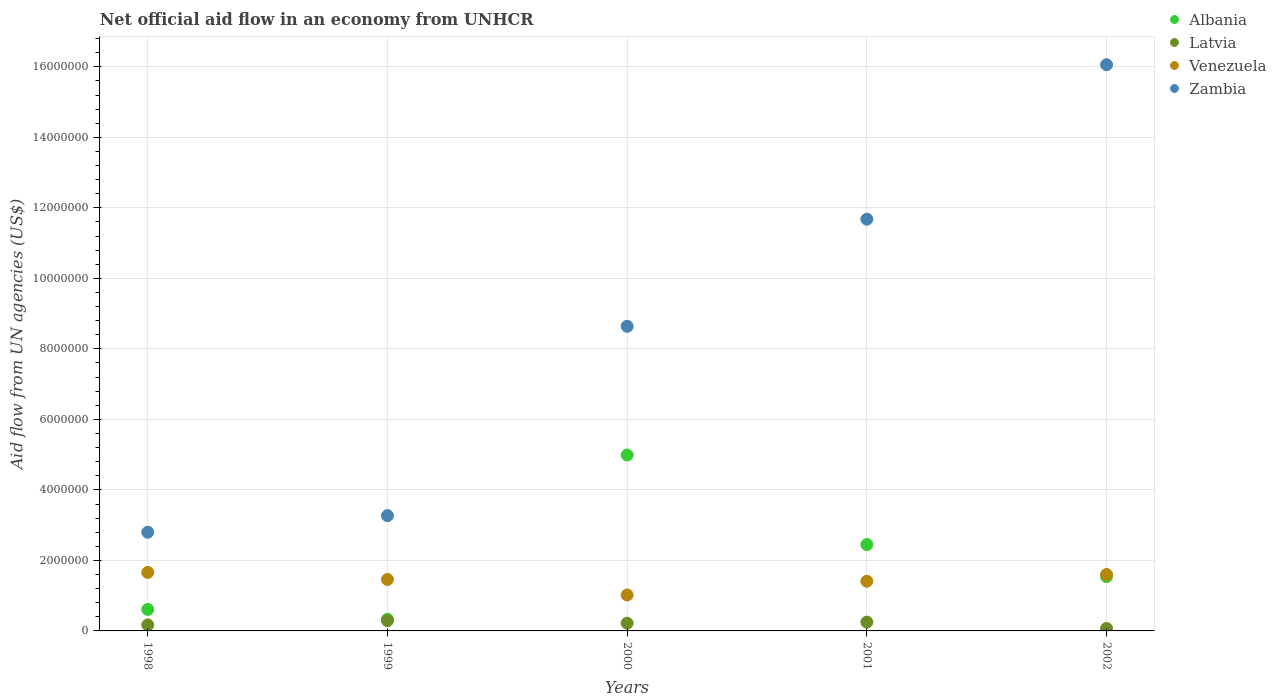Is the number of dotlines equal to the number of legend labels?
Make the answer very short. Yes. What is the net official aid flow in Venezuela in 2001?
Offer a terse response. 1.41e+06. Across all years, what is the maximum net official aid flow in Venezuela?
Offer a very short reply. 1.66e+06. Across all years, what is the minimum net official aid flow in Venezuela?
Keep it short and to the point. 1.02e+06. In which year was the net official aid flow in Albania maximum?
Your response must be concise. 2000. What is the total net official aid flow in Latvia in the graph?
Ensure brevity in your answer.  1.00e+06. What is the difference between the net official aid flow in Albania in 2002 and the net official aid flow in Venezuela in 2000?
Your answer should be compact. 5.20e+05. What is the average net official aid flow in Zambia per year?
Give a very brief answer. 8.49e+06. In the year 2000, what is the difference between the net official aid flow in Latvia and net official aid flow in Venezuela?
Your response must be concise. -8.00e+05. What is the ratio of the net official aid flow in Albania in 1999 to that in 2001?
Offer a terse response. 0.13. Is the net official aid flow in Albania in 2000 less than that in 2001?
Your answer should be very brief. No. Is the difference between the net official aid flow in Latvia in 1998 and 1999 greater than the difference between the net official aid flow in Venezuela in 1998 and 1999?
Offer a terse response. No. What is the difference between the highest and the second highest net official aid flow in Venezuela?
Your response must be concise. 6.00e+04. What is the difference between the highest and the lowest net official aid flow in Latvia?
Your answer should be very brief. 2.20e+05. In how many years, is the net official aid flow in Venezuela greater than the average net official aid flow in Venezuela taken over all years?
Offer a terse response. 3. Is the sum of the net official aid flow in Venezuela in 1998 and 1999 greater than the maximum net official aid flow in Albania across all years?
Your answer should be very brief. No. Is it the case that in every year, the sum of the net official aid flow in Venezuela and net official aid flow in Zambia  is greater than the sum of net official aid flow in Albania and net official aid flow in Latvia?
Offer a very short reply. Yes. Is the net official aid flow in Latvia strictly less than the net official aid flow in Venezuela over the years?
Your answer should be compact. Yes. How many years are there in the graph?
Provide a succinct answer. 5. Does the graph contain any zero values?
Your answer should be compact. No. Does the graph contain grids?
Ensure brevity in your answer.  Yes. How many legend labels are there?
Ensure brevity in your answer.  4. How are the legend labels stacked?
Your answer should be very brief. Vertical. What is the title of the graph?
Keep it short and to the point. Net official aid flow in an economy from UNHCR. Does "Rwanda" appear as one of the legend labels in the graph?
Your answer should be very brief. No. What is the label or title of the Y-axis?
Provide a short and direct response. Aid flow from UN agencies (US$). What is the Aid flow from UN agencies (US$) in Albania in 1998?
Your response must be concise. 6.10e+05. What is the Aid flow from UN agencies (US$) in Venezuela in 1998?
Your response must be concise. 1.66e+06. What is the Aid flow from UN agencies (US$) in Zambia in 1998?
Keep it short and to the point. 2.80e+06. What is the Aid flow from UN agencies (US$) of Albania in 1999?
Provide a short and direct response. 3.30e+05. What is the Aid flow from UN agencies (US$) in Latvia in 1999?
Make the answer very short. 2.90e+05. What is the Aid flow from UN agencies (US$) in Venezuela in 1999?
Give a very brief answer. 1.46e+06. What is the Aid flow from UN agencies (US$) in Zambia in 1999?
Make the answer very short. 3.27e+06. What is the Aid flow from UN agencies (US$) in Albania in 2000?
Your answer should be compact. 4.99e+06. What is the Aid flow from UN agencies (US$) of Venezuela in 2000?
Your answer should be compact. 1.02e+06. What is the Aid flow from UN agencies (US$) of Zambia in 2000?
Make the answer very short. 8.64e+06. What is the Aid flow from UN agencies (US$) of Albania in 2001?
Your response must be concise. 2.45e+06. What is the Aid flow from UN agencies (US$) in Venezuela in 2001?
Ensure brevity in your answer.  1.41e+06. What is the Aid flow from UN agencies (US$) in Zambia in 2001?
Ensure brevity in your answer.  1.17e+07. What is the Aid flow from UN agencies (US$) in Albania in 2002?
Give a very brief answer. 1.54e+06. What is the Aid flow from UN agencies (US$) of Venezuela in 2002?
Keep it short and to the point. 1.60e+06. What is the Aid flow from UN agencies (US$) of Zambia in 2002?
Your answer should be very brief. 1.61e+07. Across all years, what is the maximum Aid flow from UN agencies (US$) of Albania?
Make the answer very short. 4.99e+06. Across all years, what is the maximum Aid flow from UN agencies (US$) in Venezuela?
Give a very brief answer. 1.66e+06. Across all years, what is the maximum Aid flow from UN agencies (US$) in Zambia?
Give a very brief answer. 1.61e+07. Across all years, what is the minimum Aid flow from UN agencies (US$) in Albania?
Give a very brief answer. 3.30e+05. Across all years, what is the minimum Aid flow from UN agencies (US$) in Venezuela?
Offer a terse response. 1.02e+06. Across all years, what is the minimum Aid flow from UN agencies (US$) in Zambia?
Provide a succinct answer. 2.80e+06. What is the total Aid flow from UN agencies (US$) of Albania in the graph?
Your answer should be very brief. 9.92e+06. What is the total Aid flow from UN agencies (US$) in Latvia in the graph?
Ensure brevity in your answer.  1.00e+06. What is the total Aid flow from UN agencies (US$) in Venezuela in the graph?
Offer a very short reply. 7.15e+06. What is the total Aid flow from UN agencies (US$) of Zambia in the graph?
Your response must be concise. 4.24e+07. What is the difference between the Aid flow from UN agencies (US$) of Albania in 1998 and that in 1999?
Your response must be concise. 2.80e+05. What is the difference between the Aid flow from UN agencies (US$) of Latvia in 1998 and that in 1999?
Keep it short and to the point. -1.20e+05. What is the difference between the Aid flow from UN agencies (US$) in Venezuela in 1998 and that in 1999?
Offer a very short reply. 2.00e+05. What is the difference between the Aid flow from UN agencies (US$) of Zambia in 1998 and that in 1999?
Keep it short and to the point. -4.70e+05. What is the difference between the Aid flow from UN agencies (US$) of Albania in 1998 and that in 2000?
Keep it short and to the point. -4.38e+06. What is the difference between the Aid flow from UN agencies (US$) in Venezuela in 1998 and that in 2000?
Your response must be concise. 6.40e+05. What is the difference between the Aid flow from UN agencies (US$) in Zambia in 1998 and that in 2000?
Your answer should be very brief. -5.84e+06. What is the difference between the Aid flow from UN agencies (US$) of Albania in 1998 and that in 2001?
Make the answer very short. -1.84e+06. What is the difference between the Aid flow from UN agencies (US$) of Zambia in 1998 and that in 2001?
Ensure brevity in your answer.  -8.88e+06. What is the difference between the Aid flow from UN agencies (US$) in Albania in 1998 and that in 2002?
Your answer should be compact. -9.30e+05. What is the difference between the Aid flow from UN agencies (US$) in Venezuela in 1998 and that in 2002?
Ensure brevity in your answer.  6.00e+04. What is the difference between the Aid flow from UN agencies (US$) of Zambia in 1998 and that in 2002?
Your answer should be compact. -1.33e+07. What is the difference between the Aid flow from UN agencies (US$) of Albania in 1999 and that in 2000?
Your response must be concise. -4.66e+06. What is the difference between the Aid flow from UN agencies (US$) of Venezuela in 1999 and that in 2000?
Ensure brevity in your answer.  4.40e+05. What is the difference between the Aid flow from UN agencies (US$) in Zambia in 1999 and that in 2000?
Make the answer very short. -5.37e+06. What is the difference between the Aid flow from UN agencies (US$) in Albania in 1999 and that in 2001?
Offer a very short reply. -2.12e+06. What is the difference between the Aid flow from UN agencies (US$) of Latvia in 1999 and that in 2001?
Give a very brief answer. 4.00e+04. What is the difference between the Aid flow from UN agencies (US$) of Venezuela in 1999 and that in 2001?
Offer a very short reply. 5.00e+04. What is the difference between the Aid flow from UN agencies (US$) of Zambia in 1999 and that in 2001?
Give a very brief answer. -8.41e+06. What is the difference between the Aid flow from UN agencies (US$) of Albania in 1999 and that in 2002?
Provide a short and direct response. -1.21e+06. What is the difference between the Aid flow from UN agencies (US$) in Zambia in 1999 and that in 2002?
Offer a terse response. -1.28e+07. What is the difference between the Aid flow from UN agencies (US$) of Albania in 2000 and that in 2001?
Offer a terse response. 2.54e+06. What is the difference between the Aid flow from UN agencies (US$) in Latvia in 2000 and that in 2001?
Keep it short and to the point. -3.00e+04. What is the difference between the Aid flow from UN agencies (US$) of Venezuela in 2000 and that in 2001?
Your response must be concise. -3.90e+05. What is the difference between the Aid flow from UN agencies (US$) of Zambia in 2000 and that in 2001?
Give a very brief answer. -3.04e+06. What is the difference between the Aid flow from UN agencies (US$) of Albania in 2000 and that in 2002?
Make the answer very short. 3.45e+06. What is the difference between the Aid flow from UN agencies (US$) of Venezuela in 2000 and that in 2002?
Your response must be concise. -5.80e+05. What is the difference between the Aid flow from UN agencies (US$) of Zambia in 2000 and that in 2002?
Keep it short and to the point. -7.42e+06. What is the difference between the Aid flow from UN agencies (US$) of Albania in 2001 and that in 2002?
Your answer should be compact. 9.10e+05. What is the difference between the Aid flow from UN agencies (US$) in Zambia in 2001 and that in 2002?
Offer a terse response. -4.38e+06. What is the difference between the Aid flow from UN agencies (US$) in Albania in 1998 and the Aid flow from UN agencies (US$) in Latvia in 1999?
Your answer should be very brief. 3.20e+05. What is the difference between the Aid flow from UN agencies (US$) of Albania in 1998 and the Aid flow from UN agencies (US$) of Venezuela in 1999?
Give a very brief answer. -8.50e+05. What is the difference between the Aid flow from UN agencies (US$) of Albania in 1998 and the Aid flow from UN agencies (US$) of Zambia in 1999?
Keep it short and to the point. -2.66e+06. What is the difference between the Aid flow from UN agencies (US$) in Latvia in 1998 and the Aid flow from UN agencies (US$) in Venezuela in 1999?
Provide a short and direct response. -1.29e+06. What is the difference between the Aid flow from UN agencies (US$) of Latvia in 1998 and the Aid flow from UN agencies (US$) of Zambia in 1999?
Offer a very short reply. -3.10e+06. What is the difference between the Aid flow from UN agencies (US$) in Venezuela in 1998 and the Aid flow from UN agencies (US$) in Zambia in 1999?
Ensure brevity in your answer.  -1.61e+06. What is the difference between the Aid flow from UN agencies (US$) in Albania in 1998 and the Aid flow from UN agencies (US$) in Venezuela in 2000?
Keep it short and to the point. -4.10e+05. What is the difference between the Aid flow from UN agencies (US$) in Albania in 1998 and the Aid flow from UN agencies (US$) in Zambia in 2000?
Ensure brevity in your answer.  -8.03e+06. What is the difference between the Aid flow from UN agencies (US$) in Latvia in 1998 and the Aid flow from UN agencies (US$) in Venezuela in 2000?
Make the answer very short. -8.50e+05. What is the difference between the Aid flow from UN agencies (US$) of Latvia in 1998 and the Aid flow from UN agencies (US$) of Zambia in 2000?
Offer a very short reply. -8.47e+06. What is the difference between the Aid flow from UN agencies (US$) of Venezuela in 1998 and the Aid flow from UN agencies (US$) of Zambia in 2000?
Your answer should be very brief. -6.98e+06. What is the difference between the Aid flow from UN agencies (US$) in Albania in 1998 and the Aid flow from UN agencies (US$) in Venezuela in 2001?
Give a very brief answer. -8.00e+05. What is the difference between the Aid flow from UN agencies (US$) of Albania in 1998 and the Aid flow from UN agencies (US$) of Zambia in 2001?
Your answer should be compact. -1.11e+07. What is the difference between the Aid flow from UN agencies (US$) of Latvia in 1998 and the Aid flow from UN agencies (US$) of Venezuela in 2001?
Offer a terse response. -1.24e+06. What is the difference between the Aid flow from UN agencies (US$) of Latvia in 1998 and the Aid flow from UN agencies (US$) of Zambia in 2001?
Your response must be concise. -1.15e+07. What is the difference between the Aid flow from UN agencies (US$) in Venezuela in 1998 and the Aid flow from UN agencies (US$) in Zambia in 2001?
Provide a succinct answer. -1.00e+07. What is the difference between the Aid flow from UN agencies (US$) in Albania in 1998 and the Aid flow from UN agencies (US$) in Latvia in 2002?
Ensure brevity in your answer.  5.40e+05. What is the difference between the Aid flow from UN agencies (US$) of Albania in 1998 and the Aid flow from UN agencies (US$) of Venezuela in 2002?
Your answer should be compact. -9.90e+05. What is the difference between the Aid flow from UN agencies (US$) of Albania in 1998 and the Aid flow from UN agencies (US$) of Zambia in 2002?
Provide a short and direct response. -1.54e+07. What is the difference between the Aid flow from UN agencies (US$) of Latvia in 1998 and the Aid flow from UN agencies (US$) of Venezuela in 2002?
Your response must be concise. -1.43e+06. What is the difference between the Aid flow from UN agencies (US$) in Latvia in 1998 and the Aid flow from UN agencies (US$) in Zambia in 2002?
Your response must be concise. -1.59e+07. What is the difference between the Aid flow from UN agencies (US$) in Venezuela in 1998 and the Aid flow from UN agencies (US$) in Zambia in 2002?
Keep it short and to the point. -1.44e+07. What is the difference between the Aid flow from UN agencies (US$) in Albania in 1999 and the Aid flow from UN agencies (US$) in Venezuela in 2000?
Your response must be concise. -6.90e+05. What is the difference between the Aid flow from UN agencies (US$) of Albania in 1999 and the Aid flow from UN agencies (US$) of Zambia in 2000?
Offer a very short reply. -8.31e+06. What is the difference between the Aid flow from UN agencies (US$) of Latvia in 1999 and the Aid flow from UN agencies (US$) of Venezuela in 2000?
Provide a short and direct response. -7.30e+05. What is the difference between the Aid flow from UN agencies (US$) in Latvia in 1999 and the Aid flow from UN agencies (US$) in Zambia in 2000?
Your response must be concise. -8.35e+06. What is the difference between the Aid flow from UN agencies (US$) in Venezuela in 1999 and the Aid flow from UN agencies (US$) in Zambia in 2000?
Offer a very short reply. -7.18e+06. What is the difference between the Aid flow from UN agencies (US$) of Albania in 1999 and the Aid flow from UN agencies (US$) of Latvia in 2001?
Offer a very short reply. 8.00e+04. What is the difference between the Aid flow from UN agencies (US$) of Albania in 1999 and the Aid flow from UN agencies (US$) of Venezuela in 2001?
Give a very brief answer. -1.08e+06. What is the difference between the Aid flow from UN agencies (US$) in Albania in 1999 and the Aid flow from UN agencies (US$) in Zambia in 2001?
Ensure brevity in your answer.  -1.14e+07. What is the difference between the Aid flow from UN agencies (US$) of Latvia in 1999 and the Aid flow from UN agencies (US$) of Venezuela in 2001?
Offer a very short reply. -1.12e+06. What is the difference between the Aid flow from UN agencies (US$) of Latvia in 1999 and the Aid flow from UN agencies (US$) of Zambia in 2001?
Offer a terse response. -1.14e+07. What is the difference between the Aid flow from UN agencies (US$) of Venezuela in 1999 and the Aid flow from UN agencies (US$) of Zambia in 2001?
Your response must be concise. -1.02e+07. What is the difference between the Aid flow from UN agencies (US$) of Albania in 1999 and the Aid flow from UN agencies (US$) of Latvia in 2002?
Offer a terse response. 2.60e+05. What is the difference between the Aid flow from UN agencies (US$) in Albania in 1999 and the Aid flow from UN agencies (US$) in Venezuela in 2002?
Your answer should be compact. -1.27e+06. What is the difference between the Aid flow from UN agencies (US$) of Albania in 1999 and the Aid flow from UN agencies (US$) of Zambia in 2002?
Provide a succinct answer. -1.57e+07. What is the difference between the Aid flow from UN agencies (US$) of Latvia in 1999 and the Aid flow from UN agencies (US$) of Venezuela in 2002?
Ensure brevity in your answer.  -1.31e+06. What is the difference between the Aid flow from UN agencies (US$) of Latvia in 1999 and the Aid flow from UN agencies (US$) of Zambia in 2002?
Provide a short and direct response. -1.58e+07. What is the difference between the Aid flow from UN agencies (US$) of Venezuela in 1999 and the Aid flow from UN agencies (US$) of Zambia in 2002?
Offer a very short reply. -1.46e+07. What is the difference between the Aid flow from UN agencies (US$) of Albania in 2000 and the Aid flow from UN agencies (US$) of Latvia in 2001?
Your answer should be compact. 4.74e+06. What is the difference between the Aid flow from UN agencies (US$) of Albania in 2000 and the Aid flow from UN agencies (US$) of Venezuela in 2001?
Make the answer very short. 3.58e+06. What is the difference between the Aid flow from UN agencies (US$) in Albania in 2000 and the Aid flow from UN agencies (US$) in Zambia in 2001?
Provide a succinct answer. -6.69e+06. What is the difference between the Aid flow from UN agencies (US$) of Latvia in 2000 and the Aid flow from UN agencies (US$) of Venezuela in 2001?
Ensure brevity in your answer.  -1.19e+06. What is the difference between the Aid flow from UN agencies (US$) in Latvia in 2000 and the Aid flow from UN agencies (US$) in Zambia in 2001?
Give a very brief answer. -1.15e+07. What is the difference between the Aid flow from UN agencies (US$) of Venezuela in 2000 and the Aid flow from UN agencies (US$) of Zambia in 2001?
Your response must be concise. -1.07e+07. What is the difference between the Aid flow from UN agencies (US$) of Albania in 2000 and the Aid flow from UN agencies (US$) of Latvia in 2002?
Make the answer very short. 4.92e+06. What is the difference between the Aid flow from UN agencies (US$) of Albania in 2000 and the Aid flow from UN agencies (US$) of Venezuela in 2002?
Your response must be concise. 3.39e+06. What is the difference between the Aid flow from UN agencies (US$) in Albania in 2000 and the Aid flow from UN agencies (US$) in Zambia in 2002?
Your response must be concise. -1.11e+07. What is the difference between the Aid flow from UN agencies (US$) in Latvia in 2000 and the Aid flow from UN agencies (US$) in Venezuela in 2002?
Provide a succinct answer. -1.38e+06. What is the difference between the Aid flow from UN agencies (US$) in Latvia in 2000 and the Aid flow from UN agencies (US$) in Zambia in 2002?
Give a very brief answer. -1.58e+07. What is the difference between the Aid flow from UN agencies (US$) in Venezuela in 2000 and the Aid flow from UN agencies (US$) in Zambia in 2002?
Your answer should be compact. -1.50e+07. What is the difference between the Aid flow from UN agencies (US$) in Albania in 2001 and the Aid flow from UN agencies (US$) in Latvia in 2002?
Offer a very short reply. 2.38e+06. What is the difference between the Aid flow from UN agencies (US$) in Albania in 2001 and the Aid flow from UN agencies (US$) in Venezuela in 2002?
Your answer should be very brief. 8.50e+05. What is the difference between the Aid flow from UN agencies (US$) in Albania in 2001 and the Aid flow from UN agencies (US$) in Zambia in 2002?
Provide a short and direct response. -1.36e+07. What is the difference between the Aid flow from UN agencies (US$) of Latvia in 2001 and the Aid flow from UN agencies (US$) of Venezuela in 2002?
Provide a short and direct response. -1.35e+06. What is the difference between the Aid flow from UN agencies (US$) of Latvia in 2001 and the Aid flow from UN agencies (US$) of Zambia in 2002?
Provide a succinct answer. -1.58e+07. What is the difference between the Aid flow from UN agencies (US$) in Venezuela in 2001 and the Aid flow from UN agencies (US$) in Zambia in 2002?
Provide a succinct answer. -1.46e+07. What is the average Aid flow from UN agencies (US$) in Albania per year?
Your answer should be very brief. 1.98e+06. What is the average Aid flow from UN agencies (US$) in Venezuela per year?
Give a very brief answer. 1.43e+06. What is the average Aid flow from UN agencies (US$) in Zambia per year?
Your answer should be compact. 8.49e+06. In the year 1998, what is the difference between the Aid flow from UN agencies (US$) in Albania and Aid flow from UN agencies (US$) in Latvia?
Your answer should be compact. 4.40e+05. In the year 1998, what is the difference between the Aid flow from UN agencies (US$) in Albania and Aid flow from UN agencies (US$) in Venezuela?
Ensure brevity in your answer.  -1.05e+06. In the year 1998, what is the difference between the Aid flow from UN agencies (US$) in Albania and Aid flow from UN agencies (US$) in Zambia?
Your response must be concise. -2.19e+06. In the year 1998, what is the difference between the Aid flow from UN agencies (US$) of Latvia and Aid flow from UN agencies (US$) of Venezuela?
Your answer should be very brief. -1.49e+06. In the year 1998, what is the difference between the Aid flow from UN agencies (US$) in Latvia and Aid flow from UN agencies (US$) in Zambia?
Ensure brevity in your answer.  -2.63e+06. In the year 1998, what is the difference between the Aid flow from UN agencies (US$) of Venezuela and Aid flow from UN agencies (US$) of Zambia?
Provide a succinct answer. -1.14e+06. In the year 1999, what is the difference between the Aid flow from UN agencies (US$) of Albania and Aid flow from UN agencies (US$) of Venezuela?
Keep it short and to the point. -1.13e+06. In the year 1999, what is the difference between the Aid flow from UN agencies (US$) of Albania and Aid flow from UN agencies (US$) of Zambia?
Provide a short and direct response. -2.94e+06. In the year 1999, what is the difference between the Aid flow from UN agencies (US$) of Latvia and Aid flow from UN agencies (US$) of Venezuela?
Provide a succinct answer. -1.17e+06. In the year 1999, what is the difference between the Aid flow from UN agencies (US$) in Latvia and Aid flow from UN agencies (US$) in Zambia?
Give a very brief answer. -2.98e+06. In the year 1999, what is the difference between the Aid flow from UN agencies (US$) of Venezuela and Aid flow from UN agencies (US$) of Zambia?
Give a very brief answer. -1.81e+06. In the year 2000, what is the difference between the Aid flow from UN agencies (US$) of Albania and Aid flow from UN agencies (US$) of Latvia?
Keep it short and to the point. 4.77e+06. In the year 2000, what is the difference between the Aid flow from UN agencies (US$) of Albania and Aid flow from UN agencies (US$) of Venezuela?
Your answer should be very brief. 3.97e+06. In the year 2000, what is the difference between the Aid flow from UN agencies (US$) of Albania and Aid flow from UN agencies (US$) of Zambia?
Offer a very short reply. -3.65e+06. In the year 2000, what is the difference between the Aid flow from UN agencies (US$) in Latvia and Aid flow from UN agencies (US$) in Venezuela?
Give a very brief answer. -8.00e+05. In the year 2000, what is the difference between the Aid flow from UN agencies (US$) of Latvia and Aid flow from UN agencies (US$) of Zambia?
Make the answer very short. -8.42e+06. In the year 2000, what is the difference between the Aid flow from UN agencies (US$) in Venezuela and Aid flow from UN agencies (US$) in Zambia?
Your answer should be compact. -7.62e+06. In the year 2001, what is the difference between the Aid flow from UN agencies (US$) in Albania and Aid flow from UN agencies (US$) in Latvia?
Offer a very short reply. 2.20e+06. In the year 2001, what is the difference between the Aid flow from UN agencies (US$) in Albania and Aid flow from UN agencies (US$) in Venezuela?
Ensure brevity in your answer.  1.04e+06. In the year 2001, what is the difference between the Aid flow from UN agencies (US$) of Albania and Aid flow from UN agencies (US$) of Zambia?
Your answer should be very brief. -9.23e+06. In the year 2001, what is the difference between the Aid flow from UN agencies (US$) of Latvia and Aid flow from UN agencies (US$) of Venezuela?
Make the answer very short. -1.16e+06. In the year 2001, what is the difference between the Aid flow from UN agencies (US$) of Latvia and Aid flow from UN agencies (US$) of Zambia?
Offer a very short reply. -1.14e+07. In the year 2001, what is the difference between the Aid flow from UN agencies (US$) of Venezuela and Aid flow from UN agencies (US$) of Zambia?
Offer a very short reply. -1.03e+07. In the year 2002, what is the difference between the Aid flow from UN agencies (US$) in Albania and Aid flow from UN agencies (US$) in Latvia?
Make the answer very short. 1.47e+06. In the year 2002, what is the difference between the Aid flow from UN agencies (US$) in Albania and Aid flow from UN agencies (US$) in Zambia?
Provide a succinct answer. -1.45e+07. In the year 2002, what is the difference between the Aid flow from UN agencies (US$) of Latvia and Aid flow from UN agencies (US$) of Venezuela?
Your answer should be compact. -1.53e+06. In the year 2002, what is the difference between the Aid flow from UN agencies (US$) in Latvia and Aid flow from UN agencies (US$) in Zambia?
Your response must be concise. -1.60e+07. In the year 2002, what is the difference between the Aid flow from UN agencies (US$) in Venezuela and Aid flow from UN agencies (US$) in Zambia?
Provide a succinct answer. -1.45e+07. What is the ratio of the Aid flow from UN agencies (US$) in Albania in 1998 to that in 1999?
Ensure brevity in your answer.  1.85. What is the ratio of the Aid flow from UN agencies (US$) of Latvia in 1998 to that in 1999?
Ensure brevity in your answer.  0.59. What is the ratio of the Aid flow from UN agencies (US$) in Venezuela in 1998 to that in 1999?
Ensure brevity in your answer.  1.14. What is the ratio of the Aid flow from UN agencies (US$) of Zambia in 1998 to that in 1999?
Your response must be concise. 0.86. What is the ratio of the Aid flow from UN agencies (US$) of Albania in 1998 to that in 2000?
Give a very brief answer. 0.12. What is the ratio of the Aid flow from UN agencies (US$) in Latvia in 1998 to that in 2000?
Make the answer very short. 0.77. What is the ratio of the Aid flow from UN agencies (US$) in Venezuela in 1998 to that in 2000?
Provide a short and direct response. 1.63. What is the ratio of the Aid flow from UN agencies (US$) in Zambia in 1998 to that in 2000?
Provide a succinct answer. 0.32. What is the ratio of the Aid flow from UN agencies (US$) in Albania in 1998 to that in 2001?
Provide a short and direct response. 0.25. What is the ratio of the Aid flow from UN agencies (US$) of Latvia in 1998 to that in 2001?
Keep it short and to the point. 0.68. What is the ratio of the Aid flow from UN agencies (US$) of Venezuela in 1998 to that in 2001?
Provide a short and direct response. 1.18. What is the ratio of the Aid flow from UN agencies (US$) of Zambia in 1998 to that in 2001?
Offer a terse response. 0.24. What is the ratio of the Aid flow from UN agencies (US$) of Albania in 1998 to that in 2002?
Ensure brevity in your answer.  0.4. What is the ratio of the Aid flow from UN agencies (US$) of Latvia in 1998 to that in 2002?
Provide a succinct answer. 2.43. What is the ratio of the Aid flow from UN agencies (US$) of Venezuela in 1998 to that in 2002?
Your answer should be very brief. 1.04. What is the ratio of the Aid flow from UN agencies (US$) in Zambia in 1998 to that in 2002?
Provide a succinct answer. 0.17. What is the ratio of the Aid flow from UN agencies (US$) in Albania in 1999 to that in 2000?
Give a very brief answer. 0.07. What is the ratio of the Aid flow from UN agencies (US$) in Latvia in 1999 to that in 2000?
Keep it short and to the point. 1.32. What is the ratio of the Aid flow from UN agencies (US$) in Venezuela in 1999 to that in 2000?
Provide a succinct answer. 1.43. What is the ratio of the Aid flow from UN agencies (US$) in Zambia in 1999 to that in 2000?
Provide a succinct answer. 0.38. What is the ratio of the Aid flow from UN agencies (US$) in Albania in 1999 to that in 2001?
Your answer should be very brief. 0.13. What is the ratio of the Aid flow from UN agencies (US$) of Latvia in 1999 to that in 2001?
Your answer should be compact. 1.16. What is the ratio of the Aid flow from UN agencies (US$) in Venezuela in 1999 to that in 2001?
Provide a short and direct response. 1.04. What is the ratio of the Aid flow from UN agencies (US$) of Zambia in 1999 to that in 2001?
Keep it short and to the point. 0.28. What is the ratio of the Aid flow from UN agencies (US$) of Albania in 1999 to that in 2002?
Your answer should be very brief. 0.21. What is the ratio of the Aid flow from UN agencies (US$) in Latvia in 1999 to that in 2002?
Provide a succinct answer. 4.14. What is the ratio of the Aid flow from UN agencies (US$) in Venezuela in 1999 to that in 2002?
Offer a very short reply. 0.91. What is the ratio of the Aid flow from UN agencies (US$) in Zambia in 1999 to that in 2002?
Offer a terse response. 0.2. What is the ratio of the Aid flow from UN agencies (US$) in Albania in 2000 to that in 2001?
Provide a short and direct response. 2.04. What is the ratio of the Aid flow from UN agencies (US$) of Venezuela in 2000 to that in 2001?
Make the answer very short. 0.72. What is the ratio of the Aid flow from UN agencies (US$) of Zambia in 2000 to that in 2001?
Keep it short and to the point. 0.74. What is the ratio of the Aid flow from UN agencies (US$) in Albania in 2000 to that in 2002?
Offer a very short reply. 3.24. What is the ratio of the Aid flow from UN agencies (US$) of Latvia in 2000 to that in 2002?
Provide a succinct answer. 3.14. What is the ratio of the Aid flow from UN agencies (US$) in Venezuela in 2000 to that in 2002?
Provide a succinct answer. 0.64. What is the ratio of the Aid flow from UN agencies (US$) in Zambia in 2000 to that in 2002?
Offer a very short reply. 0.54. What is the ratio of the Aid flow from UN agencies (US$) in Albania in 2001 to that in 2002?
Your response must be concise. 1.59. What is the ratio of the Aid flow from UN agencies (US$) in Latvia in 2001 to that in 2002?
Your answer should be very brief. 3.57. What is the ratio of the Aid flow from UN agencies (US$) of Venezuela in 2001 to that in 2002?
Your answer should be compact. 0.88. What is the ratio of the Aid flow from UN agencies (US$) of Zambia in 2001 to that in 2002?
Ensure brevity in your answer.  0.73. What is the difference between the highest and the second highest Aid flow from UN agencies (US$) of Albania?
Provide a succinct answer. 2.54e+06. What is the difference between the highest and the second highest Aid flow from UN agencies (US$) of Latvia?
Your response must be concise. 4.00e+04. What is the difference between the highest and the second highest Aid flow from UN agencies (US$) in Zambia?
Keep it short and to the point. 4.38e+06. What is the difference between the highest and the lowest Aid flow from UN agencies (US$) of Albania?
Make the answer very short. 4.66e+06. What is the difference between the highest and the lowest Aid flow from UN agencies (US$) of Venezuela?
Your response must be concise. 6.40e+05. What is the difference between the highest and the lowest Aid flow from UN agencies (US$) of Zambia?
Provide a succinct answer. 1.33e+07. 